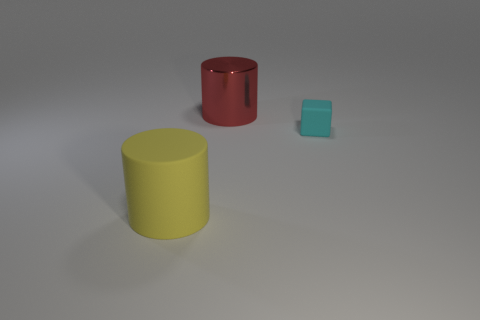How many blue objects are shiny cylinders or big matte cylinders? 0 